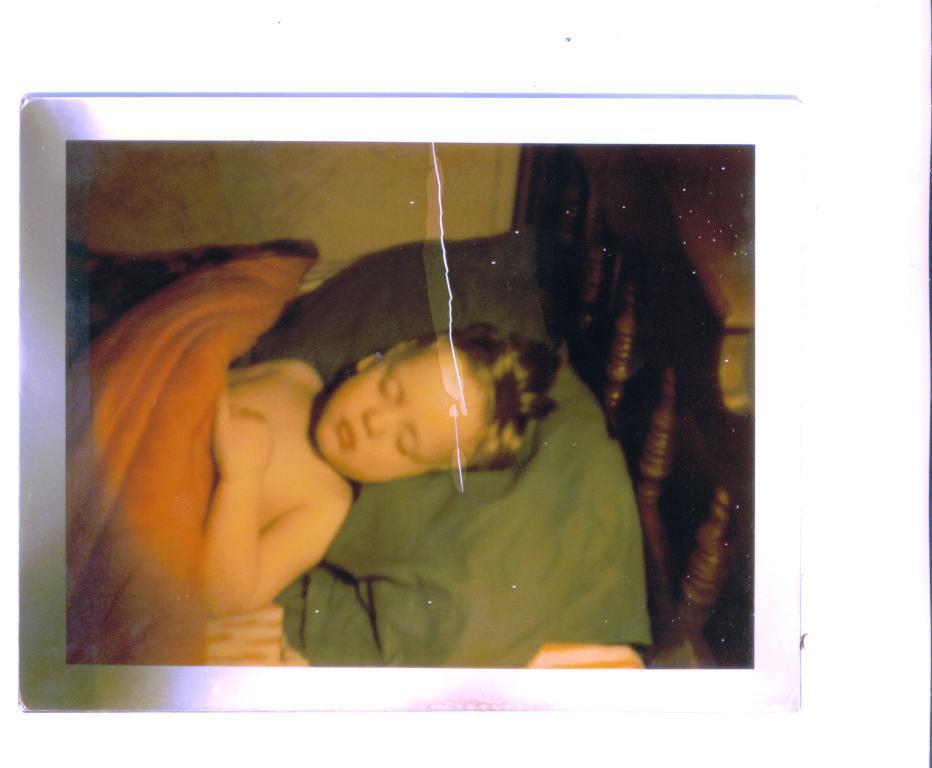In one or two sentences, can you explain what this image depicts? This picture looks like a photo frame and I can see a boy lying on the bed. 